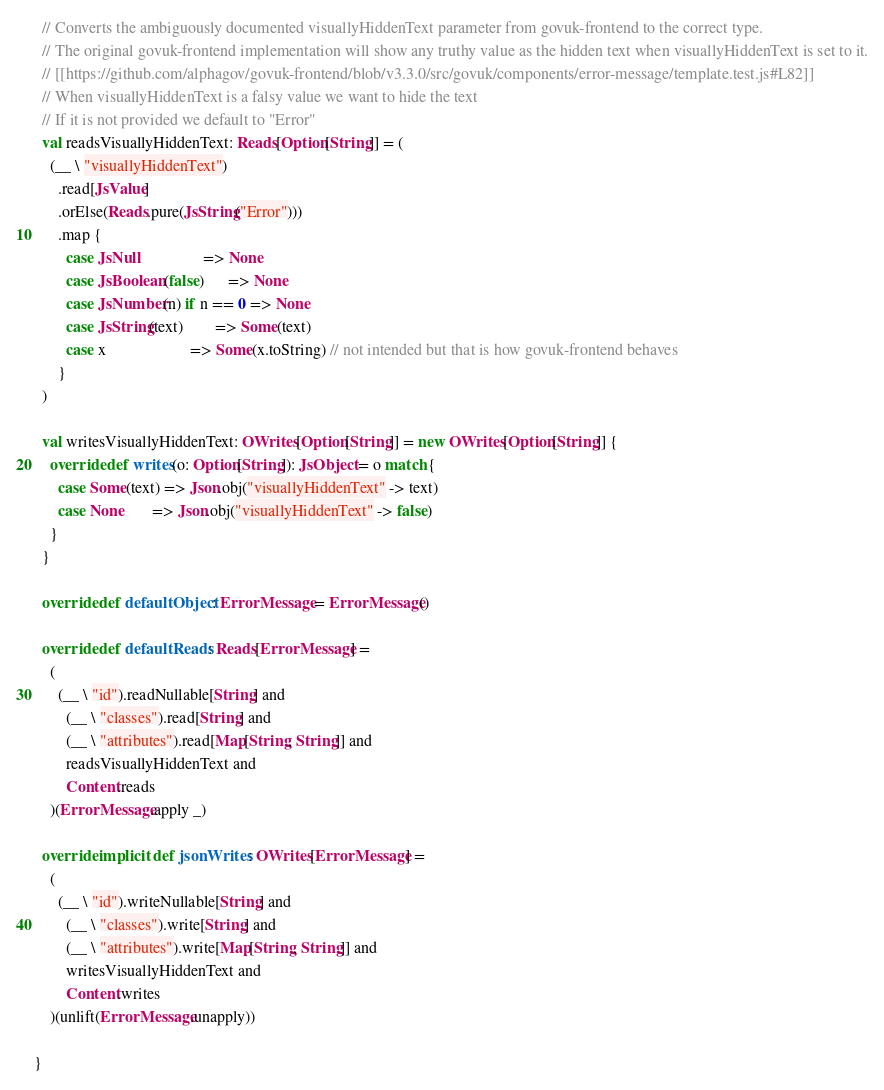Convert code to text. <code><loc_0><loc_0><loc_500><loc_500><_Scala_>  // Converts the ambiguously documented visuallyHiddenText parameter from govuk-frontend to the correct type.
  // The original govuk-frontend implementation will show any truthy value as the hidden text when visuallyHiddenText is set to it.
  // [[https://github.com/alphagov/govuk-frontend/blob/v3.3.0/src/govuk/components/error-message/template.test.js#L82]]
  // When visuallyHiddenText is a falsy value we want to hide the text
  // If it is not provided we default to "Error"
  val readsVisuallyHiddenText: Reads[Option[String]] = (
    (__ \ "visuallyHiddenText")
      .read[JsValue]
      .orElse(Reads.pure(JsString("Error")))
      .map {
        case JsNull                => None
        case JsBoolean(false)      => None
        case JsNumber(n) if n == 0 => None
        case JsString(text)        => Some(text)
        case x                     => Some(x.toString) // not intended but that is how govuk-frontend behaves
      }
  )

  val writesVisuallyHiddenText: OWrites[Option[String]] = new OWrites[Option[String]] {
    override def writes(o: Option[String]): JsObject = o match {
      case Some(text) => Json.obj("visuallyHiddenText" -> text)
      case None       => Json.obj("visuallyHiddenText" -> false)
    }
  }

  override def defaultObject: ErrorMessage = ErrorMessage()

  override def defaultReads: Reads[ErrorMessage] =
    (
      (__ \ "id").readNullable[String] and
        (__ \ "classes").read[String] and
        (__ \ "attributes").read[Map[String, String]] and
        readsVisuallyHiddenText and
        Content.reads
    )(ErrorMessage.apply _)

  override implicit def jsonWrites: OWrites[ErrorMessage] =
    (
      (__ \ "id").writeNullable[String] and
        (__ \ "classes").write[String] and
        (__ \ "attributes").write[Map[String, String]] and
        writesVisuallyHiddenText and
        Content.writes
    )(unlift(ErrorMessage.unapply))

}
</code> 